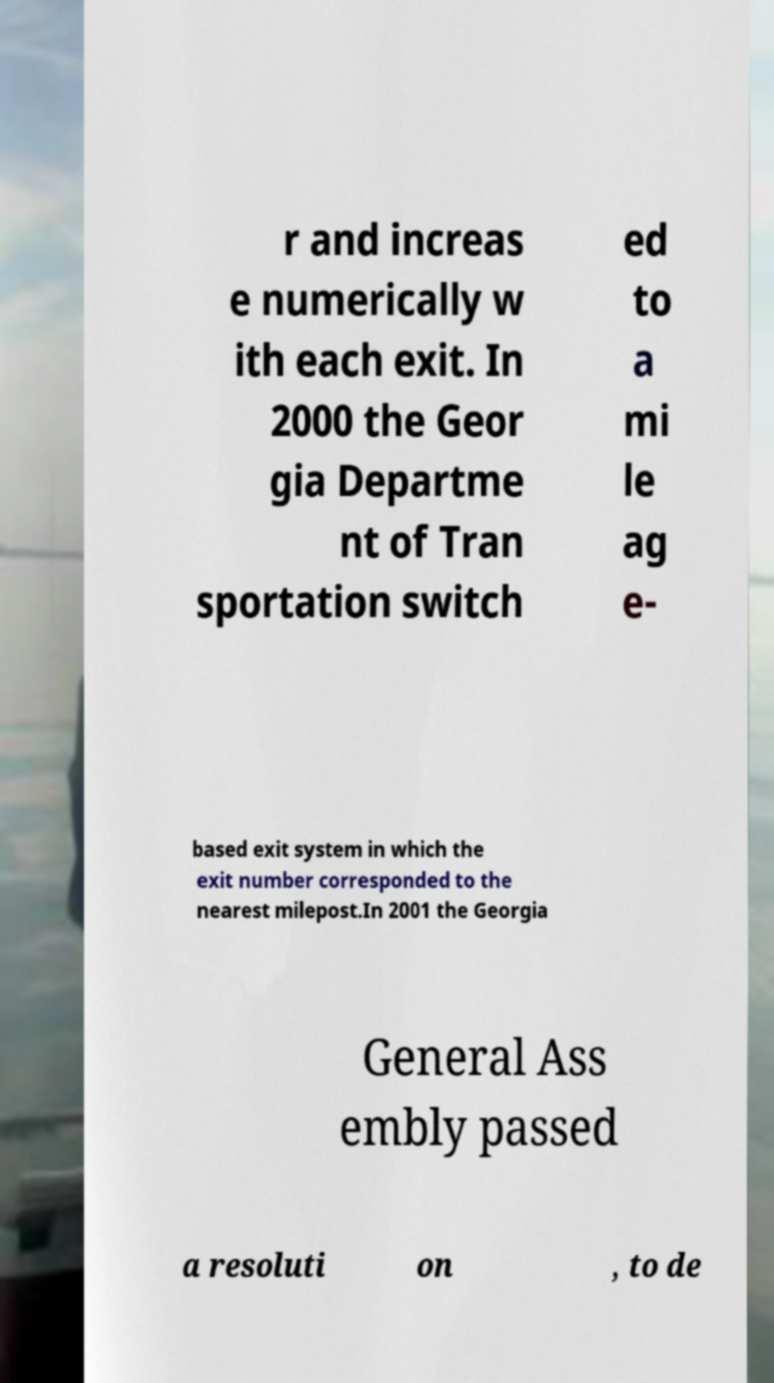Can you accurately transcribe the text from the provided image for me? r and increas e numerically w ith each exit. In 2000 the Geor gia Departme nt of Tran sportation switch ed to a mi le ag e- based exit system in which the exit number corresponded to the nearest milepost.In 2001 the Georgia General Ass embly passed a resoluti on , to de 